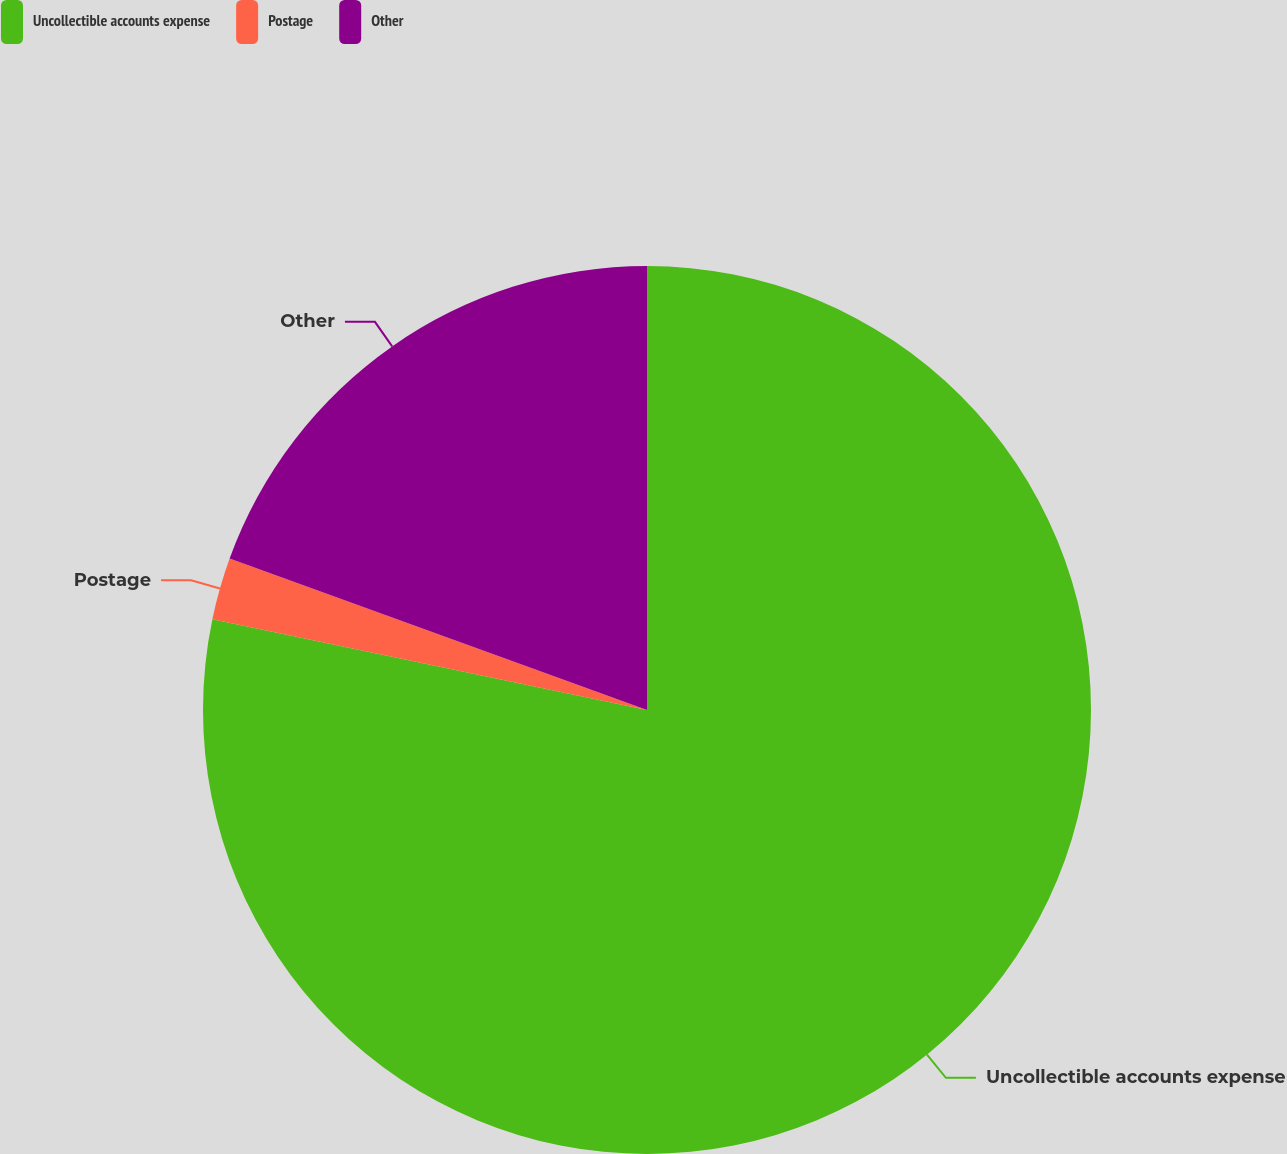Convert chart. <chart><loc_0><loc_0><loc_500><loc_500><pie_chart><fcel>Uncollectible accounts expense<fcel>Postage<fcel>Other<nl><fcel>78.28%<fcel>2.26%<fcel>19.46%<nl></chart> 